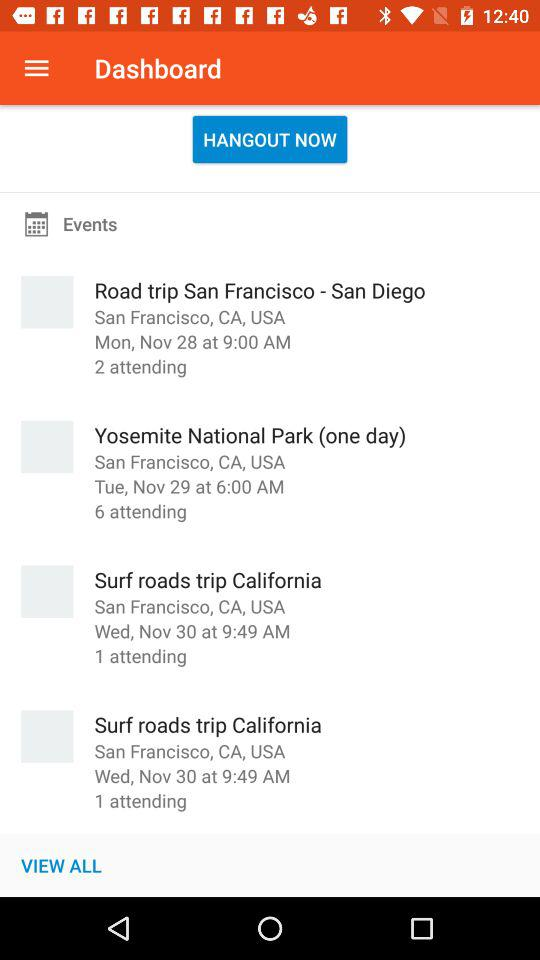What are the apps that can be used to log in to a profile? The apps are "FACEBOOK" and "Email" can be used to login. 